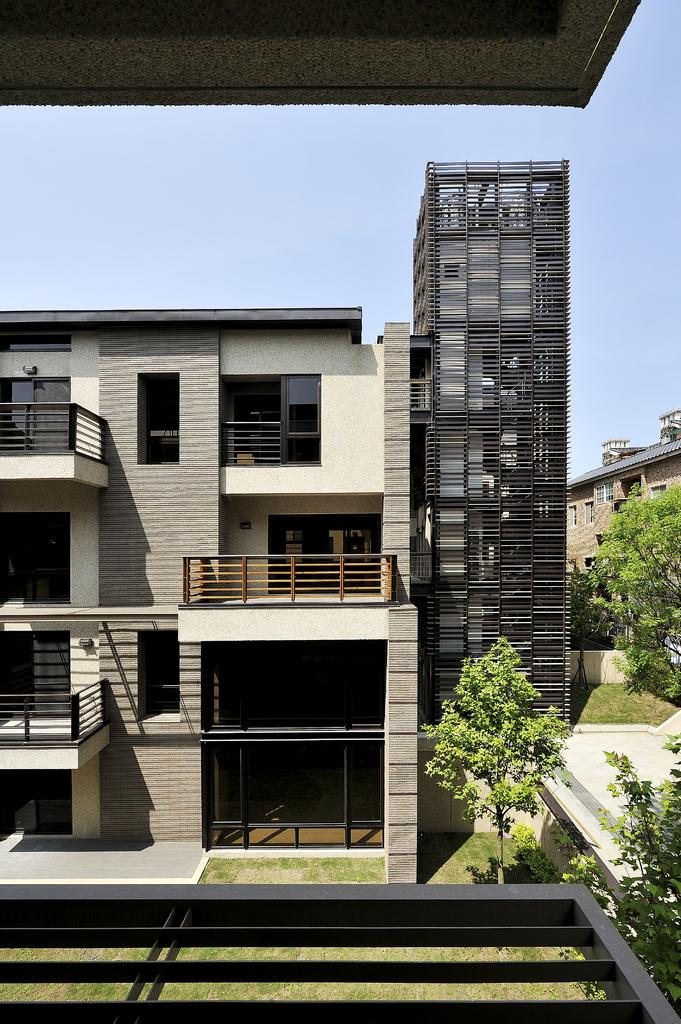What is the main subject in the middle of the image? There is a building in the middle of the image. Are there any other buildings visible in the image? Yes, there is another tall building beside the first building. What type of vegetation can be seen at the bottom of the image? Trees are present on the ground at the bottom of the image. What is visible at the top of the image? The sky is visible at the top of the image. How many leaves are on the tall building in the image? There are no leaves present on the buildings in the image, as they are constructed with materials like concrete and glass. 